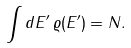Convert formula to latex. <formula><loc_0><loc_0><loc_500><loc_500>\int d E ^ { \prime } \, \varrho ( E ^ { \prime } ) = N .</formula> 